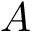Convert formula to latex. <formula><loc_0><loc_0><loc_500><loc_500>A</formula> 